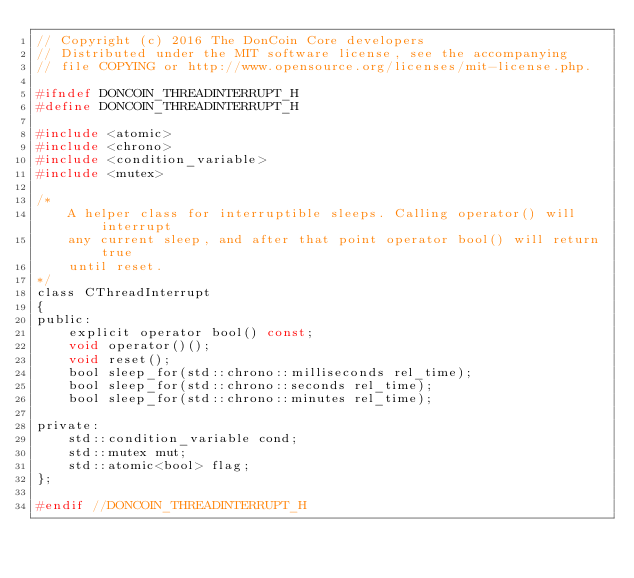Convert code to text. <code><loc_0><loc_0><loc_500><loc_500><_C_>// Copyright (c) 2016 The DonCoin Core developers
// Distributed under the MIT software license, see the accompanying
// file COPYING or http://www.opensource.org/licenses/mit-license.php.

#ifndef DONCOIN_THREADINTERRUPT_H
#define DONCOIN_THREADINTERRUPT_H

#include <atomic>
#include <chrono>
#include <condition_variable>
#include <mutex>

/*
    A helper class for interruptible sleeps. Calling operator() will interrupt
    any current sleep, and after that point operator bool() will return true
    until reset.
*/
class CThreadInterrupt
{
public:
    explicit operator bool() const;
    void operator()();
    void reset();
    bool sleep_for(std::chrono::milliseconds rel_time);
    bool sleep_for(std::chrono::seconds rel_time);
    bool sleep_for(std::chrono::minutes rel_time);

private:
    std::condition_variable cond;
    std::mutex mut;
    std::atomic<bool> flag;
};

#endif //DONCOIN_THREADINTERRUPT_H
</code> 